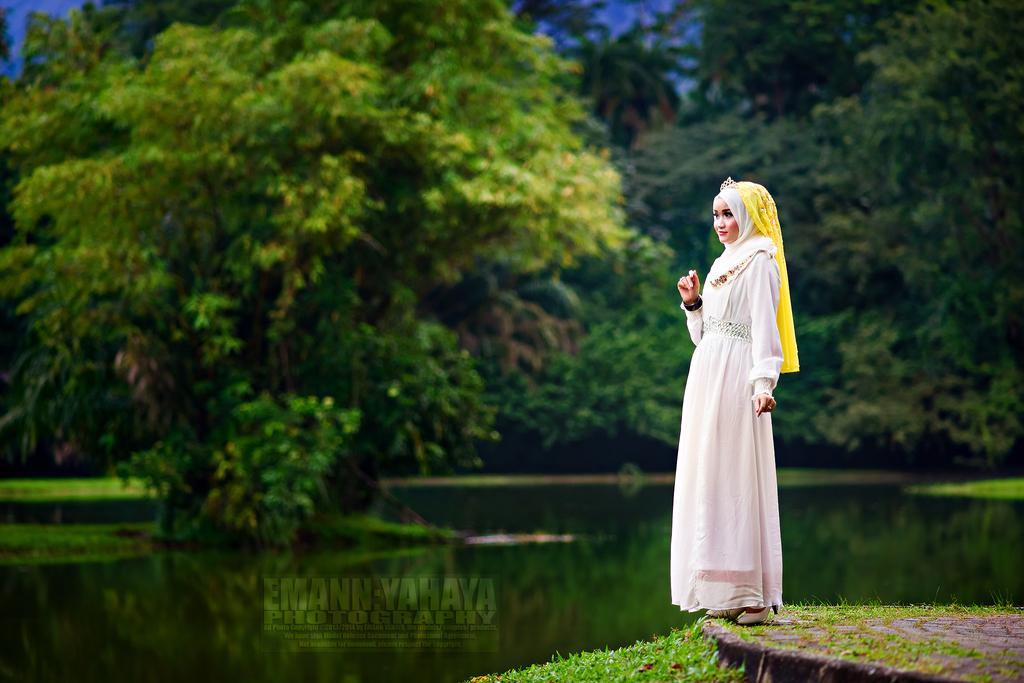What is the main subject of the image? There is a girl standing in the image. What type of terrain is visible at the bottom of the image? Grass is present at the bottom of the image. What can be seen in the middle of the image? There is water visible in the middle of the image. What type of vegetation is in the background of the image? There are trees in the background of the image. What is written or displayed at the bottom of the image? There is some text at the bottom of the image. What type of wood is being used to build the quince tree in the image? There is no quince tree or wood present in the image; it features a girl standing near water with trees in the background. 